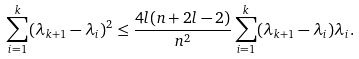Convert formula to latex. <formula><loc_0><loc_0><loc_500><loc_500>\sum _ { i = 1 } ^ { k } ( \lambda _ { k + 1 } - \lambda _ { i } ) ^ { 2 } \leq \frac { 4 l ( n + 2 l - 2 ) } { n ^ { 2 } } \sum _ { i = 1 } ^ { k } ( \lambda _ { k + 1 } - \lambda _ { i } ) \lambda _ { i } .</formula> 